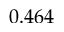Convert formula to latex. <formula><loc_0><loc_0><loc_500><loc_500>0 . 4 6 4</formula> 